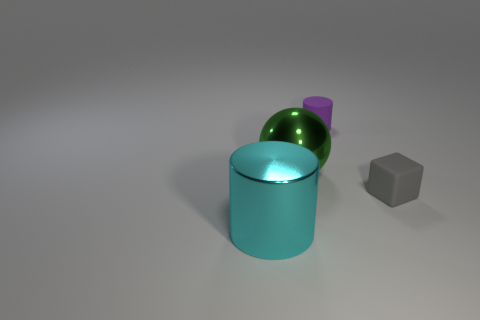Add 1 blue cylinders. How many objects exist? 5 Subtract all spheres. How many objects are left? 3 Add 4 matte cylinders. How many matte cylinders are left? 5 Add 2 tiny red shiny things. How many tiny red shiny things exist? 2 Subtract 0 green cylinders. How many objects are left? 4 Subtract all cyan metal things. Subtract all big green balls. How many objects are left? 2 